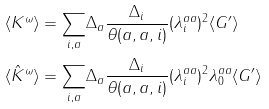<formula> <loc_0><loc_0><loc_500><loc_500>\langle K ^ { \omega } \rangle & = \underset { i , a } { \sum } \Delta _ { a } \frac { \Delta _ { i } } { \theta ( a , a , i ) } ( \lambda ^ { a a } _ { i } ) ^ { 2 } \langle G ^ { \prime } \rangle \\ \langle \hat { K } ^ { \omega } \rangle & = \underset { i , a } { \sum } \Delta _ { a } \frac { \Delta _ { i } } { \theta ( a , a , i ) } ( \lambda ^ { a a } _ { i } ) ^ { 2 } \lambda ^ { a a } _ { 0 } \langle G ^ { \prime } \rangle \</formula> 